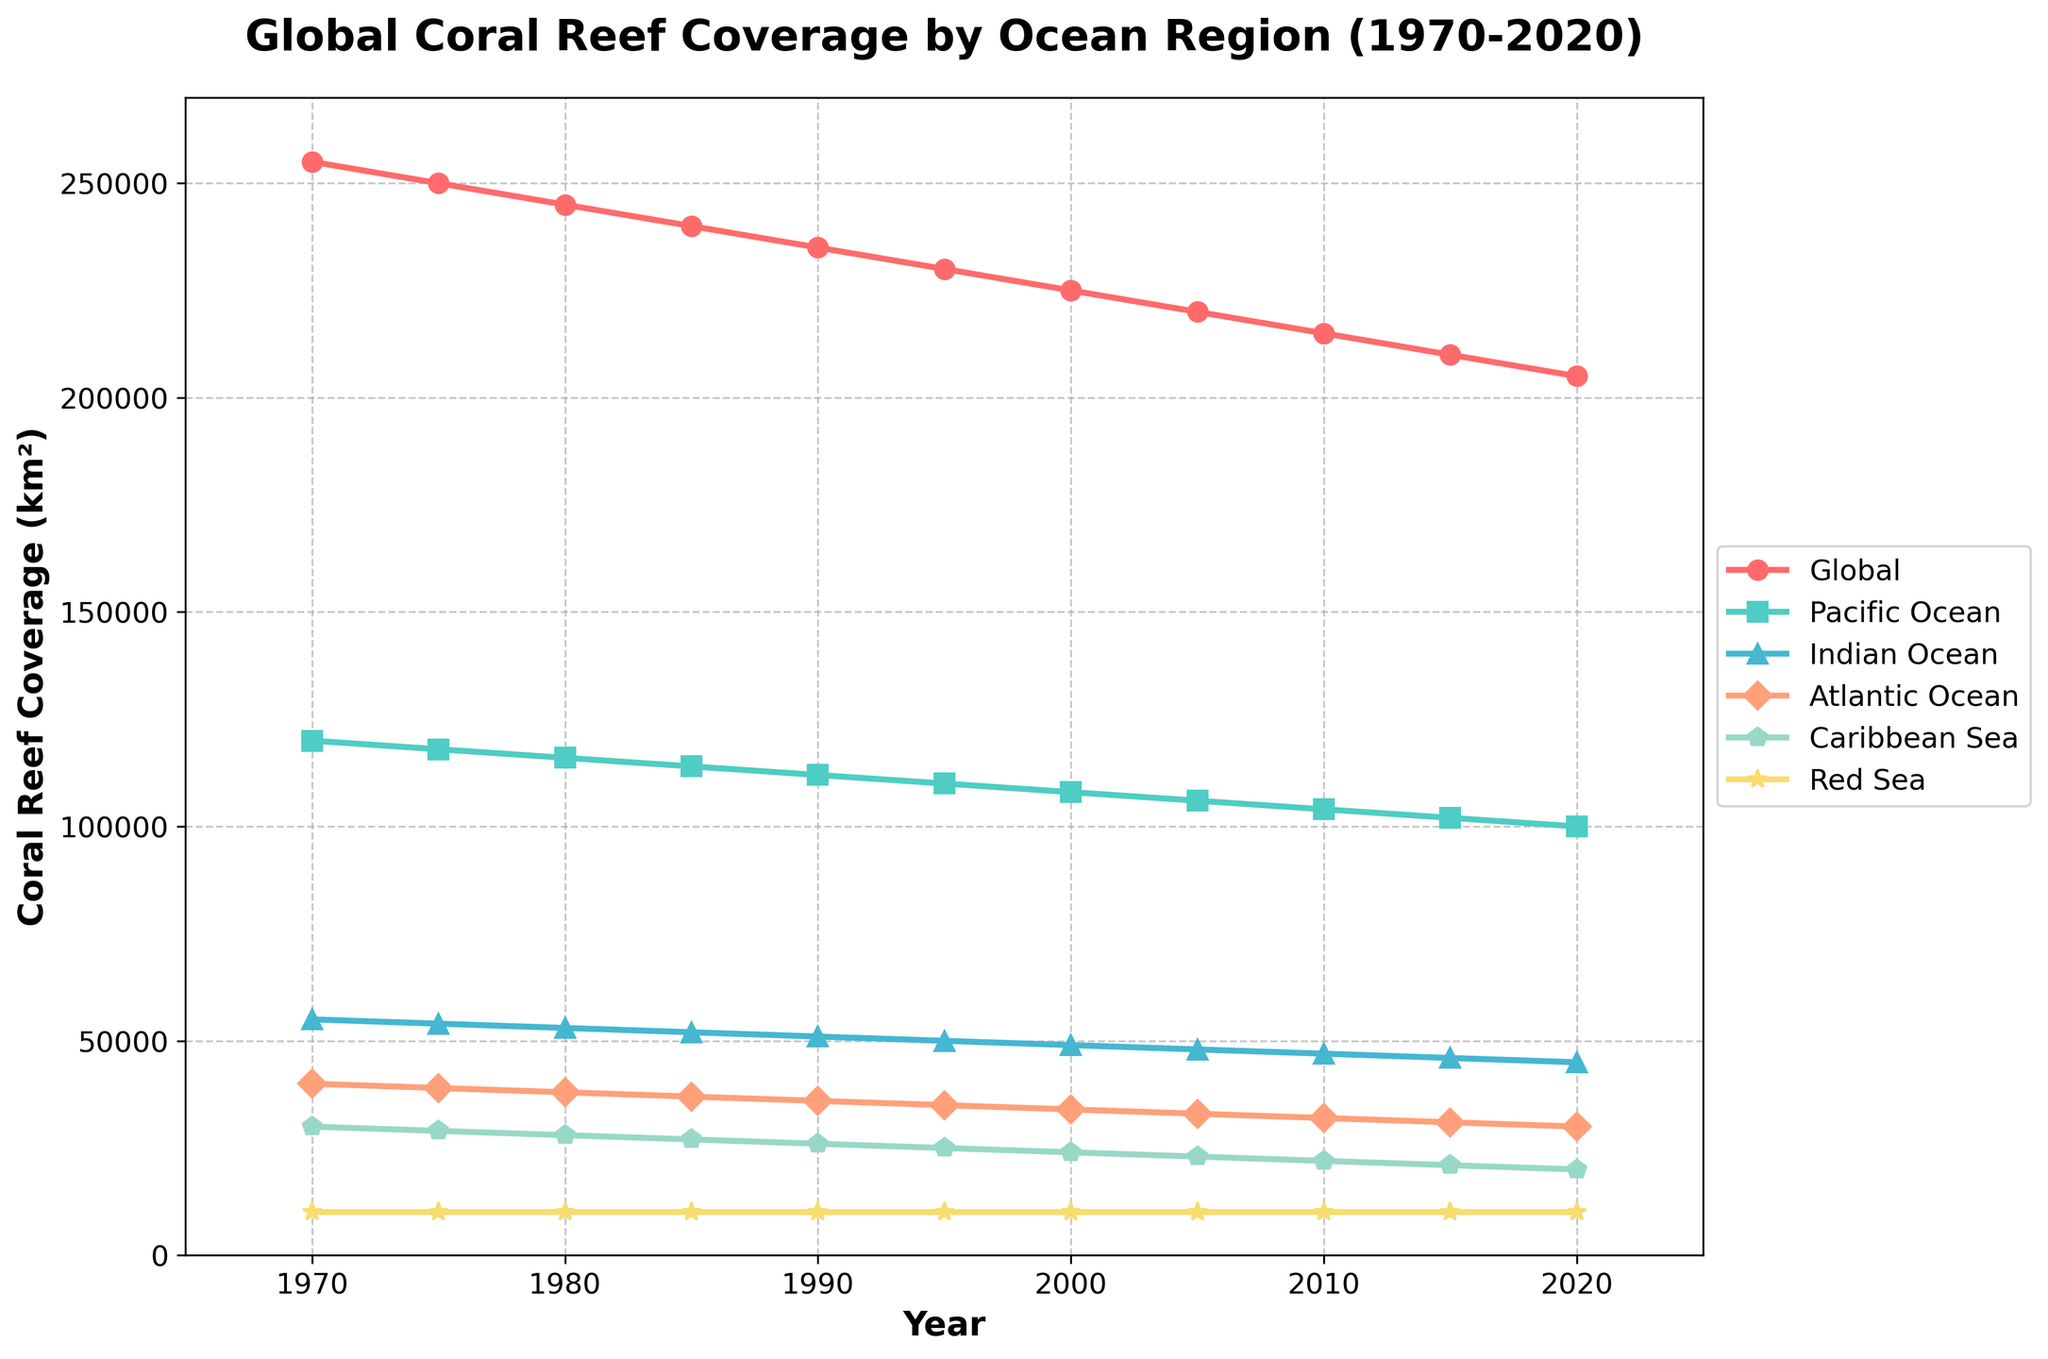Which ocean region had the highest coral reef coverage in 1970? In the figure, look for the 1970 data points. Identify the tallest line in 1970, which corresponds to the Pacific Ocean.
Answer: Pacific Ocean By how much did the global coral reef coverage decline from 1970 to 2020? Find the global coral reef coverage in 1970 (255,000 km²) and in 2020 (205,000 km²). Calculate the difference: 255,000 - 205,000 = 50,000 km².
Answer: 50,000 km² Which ocean regions maintained the same coral reef coverage throughout the period? Identify the lines that did not change in height over the period 1970-2020. The Red Sea line remained at the same value (10,000 km²).
Answer: Red Sea In which year did the Atlantic Ocean's coral reef coverage first fall below 35,000 km²? Identify the year where the line representing the Atlantic Ocean first dips below the 35,000 km² mark. In 1995, it reached 35,000 km² and in 2000 fell to 34,000 km².
Answer: 2000 Which ocean region had the smallest decline in coral reef coverage from 1970 to 2020? Calculate the difference in coral reef coverage for each ocean region from 1970 (starting point) to 2020:
Pacific Ocean: 120,000 - 100,000 = 20,000 km²
Indian Ocean: 55,000 - 45,000 = 10,000 km²
Atlantic Ocean: 40,000 - 30,000 = 10,000 km²
Caribbean Sea: 30,000 - 20,000 = 10,000 km²
Red Sea: 10,000 - 10,000 = 0 km².
Hence, the Red Sea had the smallest decline.
Answer: Red Sea 